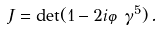<formula> <loc_0><loc_0><loc_500><loc_500>J = \det ( 1 - 2 i \varphi \gamma ^ { 5 } ) \, .</formula> 